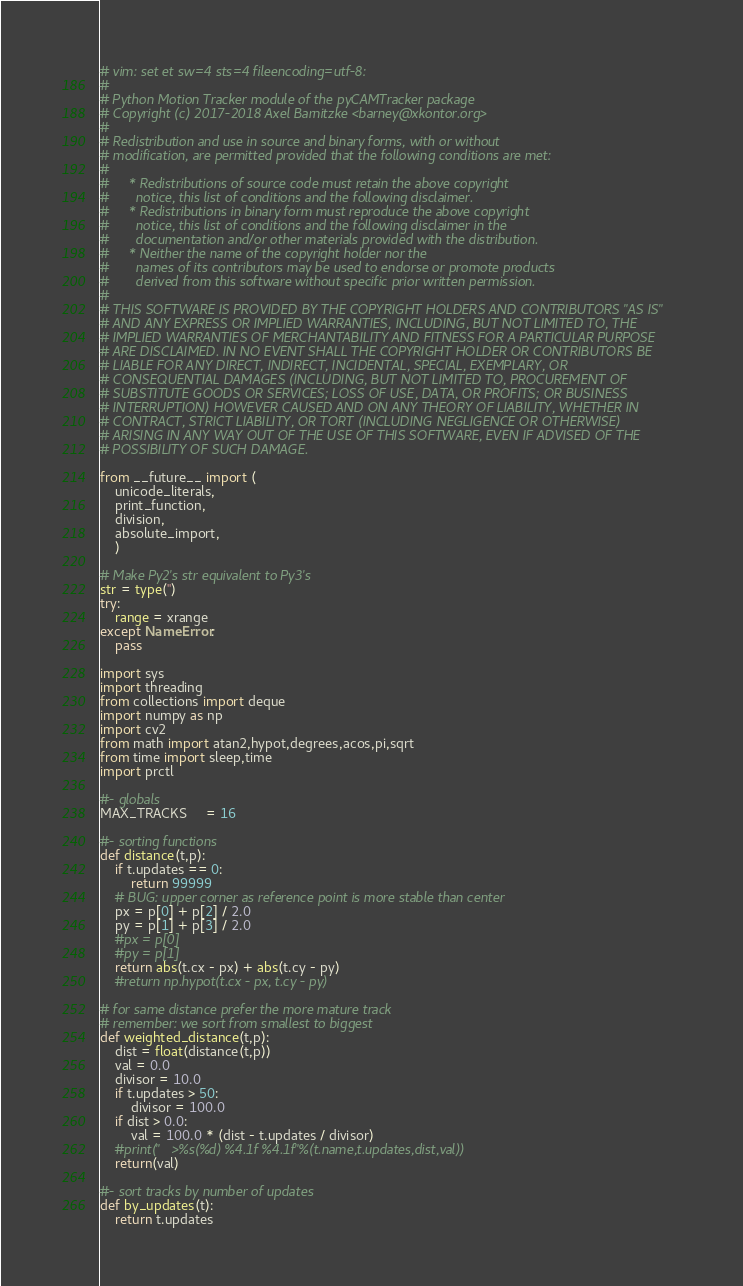<code> <loc_0><loc_0><loc_500><loc_500><_Python_># vim: set et sw=4 sts=4 fileencoding=utf-8:
#
# Python Motion Tracker module of the pyCAMTracker package
# Copyright (c) 2017-2018 Axel Barnitzke <barney@xkontor.org>
#
# Redistribution and use in source and binary forms, with or without
# modification, are permitted provided that the following conditions are met:
#
#     * Redistributions of source code must retain the above copyright
#       notice, this list of conditions and the following disclaimer.
#     * Redistributions in binary form must reproduce the above copyright
#       notice, this list of conditions and the following disclaimer in the
#       documentation and/or other materials provided with the distribution.
#     * Neither the name of the copyright holder nor the
#       names of its contributors may be used to endorse or promote products
#       derived from this software without specific prior written permission.
#
# THIS SOFTWARE IS PROVIDED BY THE COPYRIGHT HOLDERS AND CONTRIBUTORS "AS IS"
# AND ANY EXPRESS OR IMPLIED WARRANTIES, INCLUDING, BUT NOT LIMITED TO, THE
# IMPLIED WARRANTIES OF MERCHANTABILITY AND FITNESS FOR A PARTICULAR PURPOSE
# ARE DISCLAIMED. IN NO EVENT SHALL THE COPYRIGHT HOLDER OR CONTRIBUTORS BE
# LIABLE FOR ANY DIRECT, INDIRECT, INCIDENTAL, SPECIAL, EXEMPLARY, OR
# CONSEQUENTIAL DAMAGES (INCLUDING, BUT NOT LIMITED TO, PROCUREMENT OF
# SUBSTITUTE GOODS OR SERVICES; LOSS OF USE, DATA, OR PROFITS; OR BUSINESS
# INTERRUPTION) HOWEVER CAUSED AND ON ANY THEORY OF LIABILITY, WHETHER IN
# CONTRACT, STRICT LIABILITY, OR TORT (INCLUDING NEGLIGENCE OR OTHERWISE)
# ARISING IN ANY WAY OUT OF THE USE OF THIS SOFTWARE, EVEN IF ADVISED OF THE
# POSSIBILITY OF SUCH DAMAGE.

from __future__ import (
    unicode_literals,
    print_function,
    division,
    absolute_import,
    )

# Make Py2's str equivalent to Py3's
str = type('')
try:
    range = xrange
except NameError:
    pass

import sys
import threading
from collections import deque
import numpy as np
import cv2
from math import atan2,hypot,degrees,acos,pi,sqrt
from time import sleep,time
import prctl

#- globals
MAX_TRACKS     = 16

#- sorting functions
def distance(t,p):
    if t.updates == 0:
        return 99999
    # BUG: upper corner as reference point is more stable than center
    px = p[0] + p[2] / 2.0
    py = p[1] + p[3] / 2.0
    #px = p[0]
    #py = p[1]
    return abs(t.cx - px) + abs(t.cy - py)
    #return np.hypot(t.cx - px, t.cy - py)

# for same distance prefer the more mature track
# remember: we sort from smallest to biggest
def weighted_distance(t,p):
    dist = float(distance(t,p))
    val = 0.0
    divisor = 10.0
    if t.updates > 50:
        divisor = 100.0
    if dist > 0.0:
        val = 100.0 * (dist - t.updates / divisor)
    #print("   >%s(%d) %4.1f %4.1f"%(t.name,t.updates,dist,val))
    return(val)

#- sort tracks by number of updates
def by_updates(t):
    return t.updates
</code> 